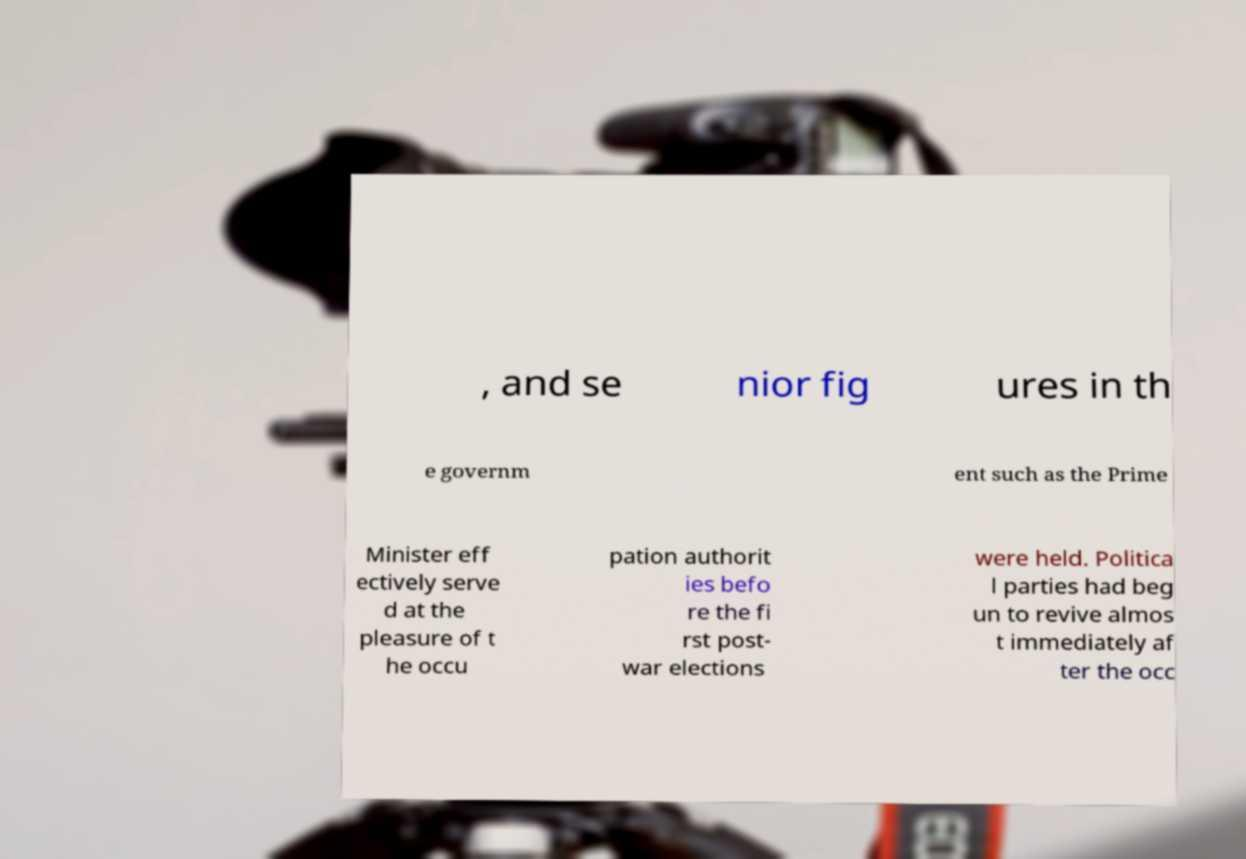Can you read and provide the text displayed in the image?This photo seems to have some interesting text. Can you extract and type it out for me? , and se nior fig ures in th e governm ent such as the Prime Minister eff ectively serve d at the pleasure of t he occu pation authorit ies befo re the fi rst post- war elections were held. Politica l parties had beg un to revive almos t immediately af ter the occ 